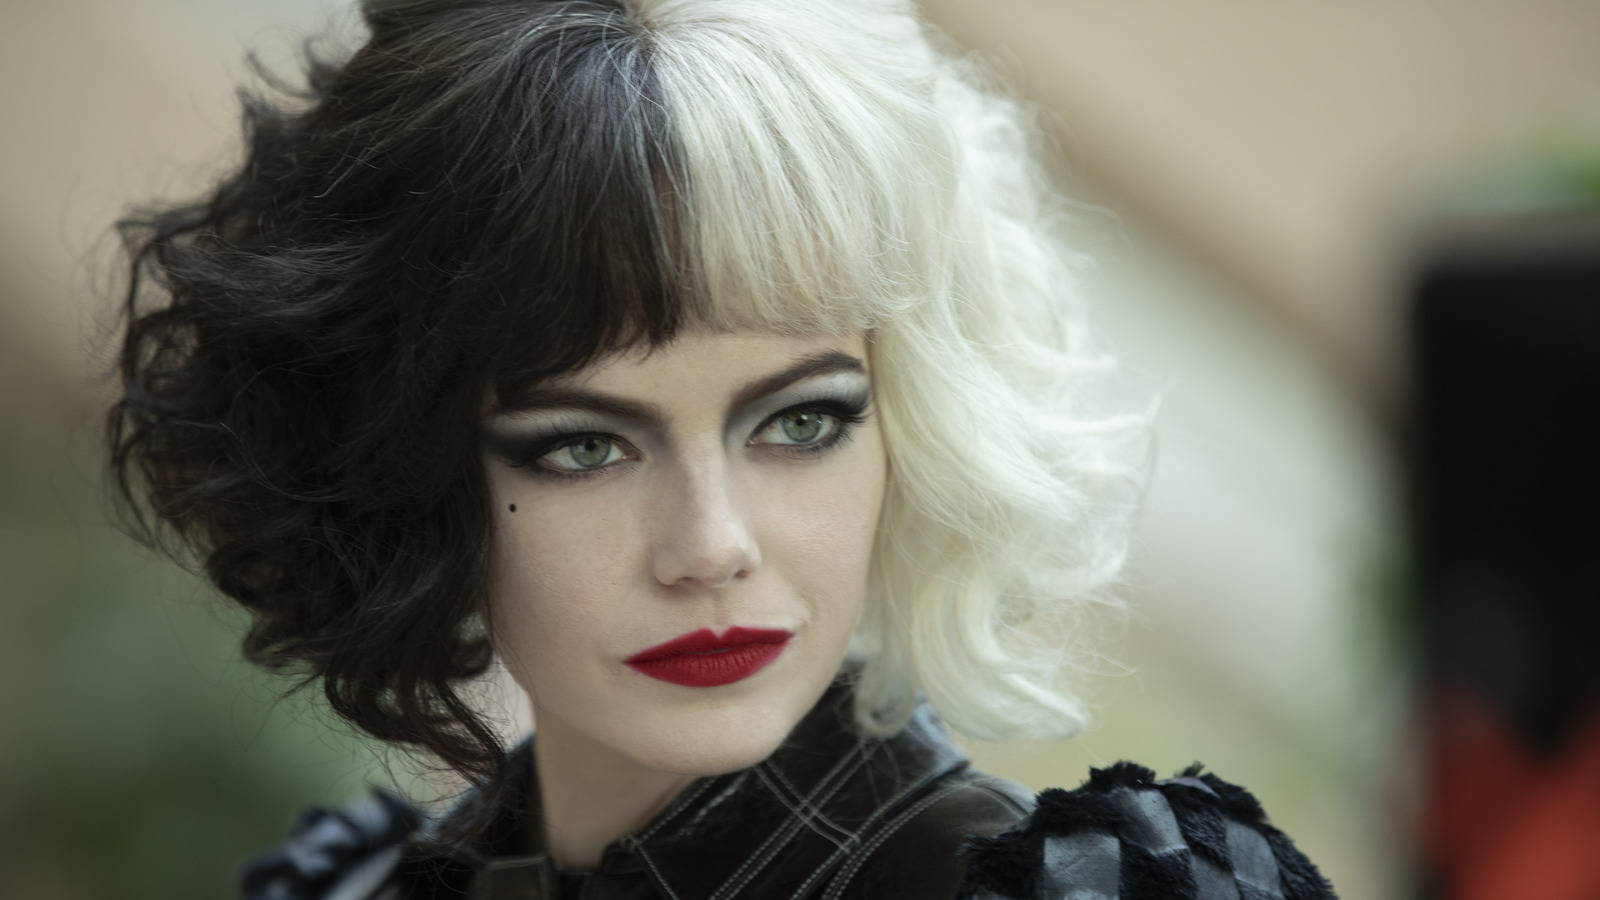Can you elaborate on the elements of the picture provided?
 In the image, we see Emma Stone, the acclaimed actress, fully immersed in her character as Cruella de Vil from the movie "Cruella". She is positioned in what appears to be a courtyard or garden, the details of which are blurred, allowing her to command full attention. 

Emma Stone's Cruella de Vil is a vision in black and white. Her hair, styled into a wig that mirrors her character's iconic look, is half jet black and half pure white. This theme extends to her attire as well - she's clad in a black leather jacket that adds an edge to her look, and a black and white feather boa that lends an air of dramatic flair.

Her makeup is as bold as her outfit. Dark eye shadow makes her eyes pop, while her red lipstick adds a splash of color to the otherwise monochrome ensemble. Her gaze is directed off to the side, and she wears a serious expression on her face, hinting at the complex nature of the character she's portraying. 